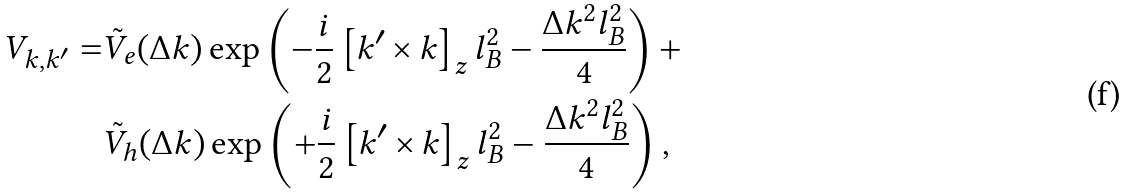<formula> <loc_0><loc_0><loc_500><loc_500>V _ { k , k ^ { \prime } } = & \tilde { V } _ { e } ( \Delta k ) \exp \left ( - \frac { i } { 2 } \left [ k ^ { \prime } \times k \right ] _ { z } l _ { B } ^ { 2 } - \frac { \Delta k ^ { 2 } l _ { B } ^ { 2 } } { 4 } \right ) + \\ & \tilde { V } _ { h } ( \Delta k ) \exp \left ( + \frac { i } { 2 } \left [ k ^ { \prime } \times k \right ] _ { z } l _ { B } ^ { 2 } - \frac { \Delta k ^ { 2 } l _ { B } ^ { 2 } } { 4 } \right ) ,</formula> 